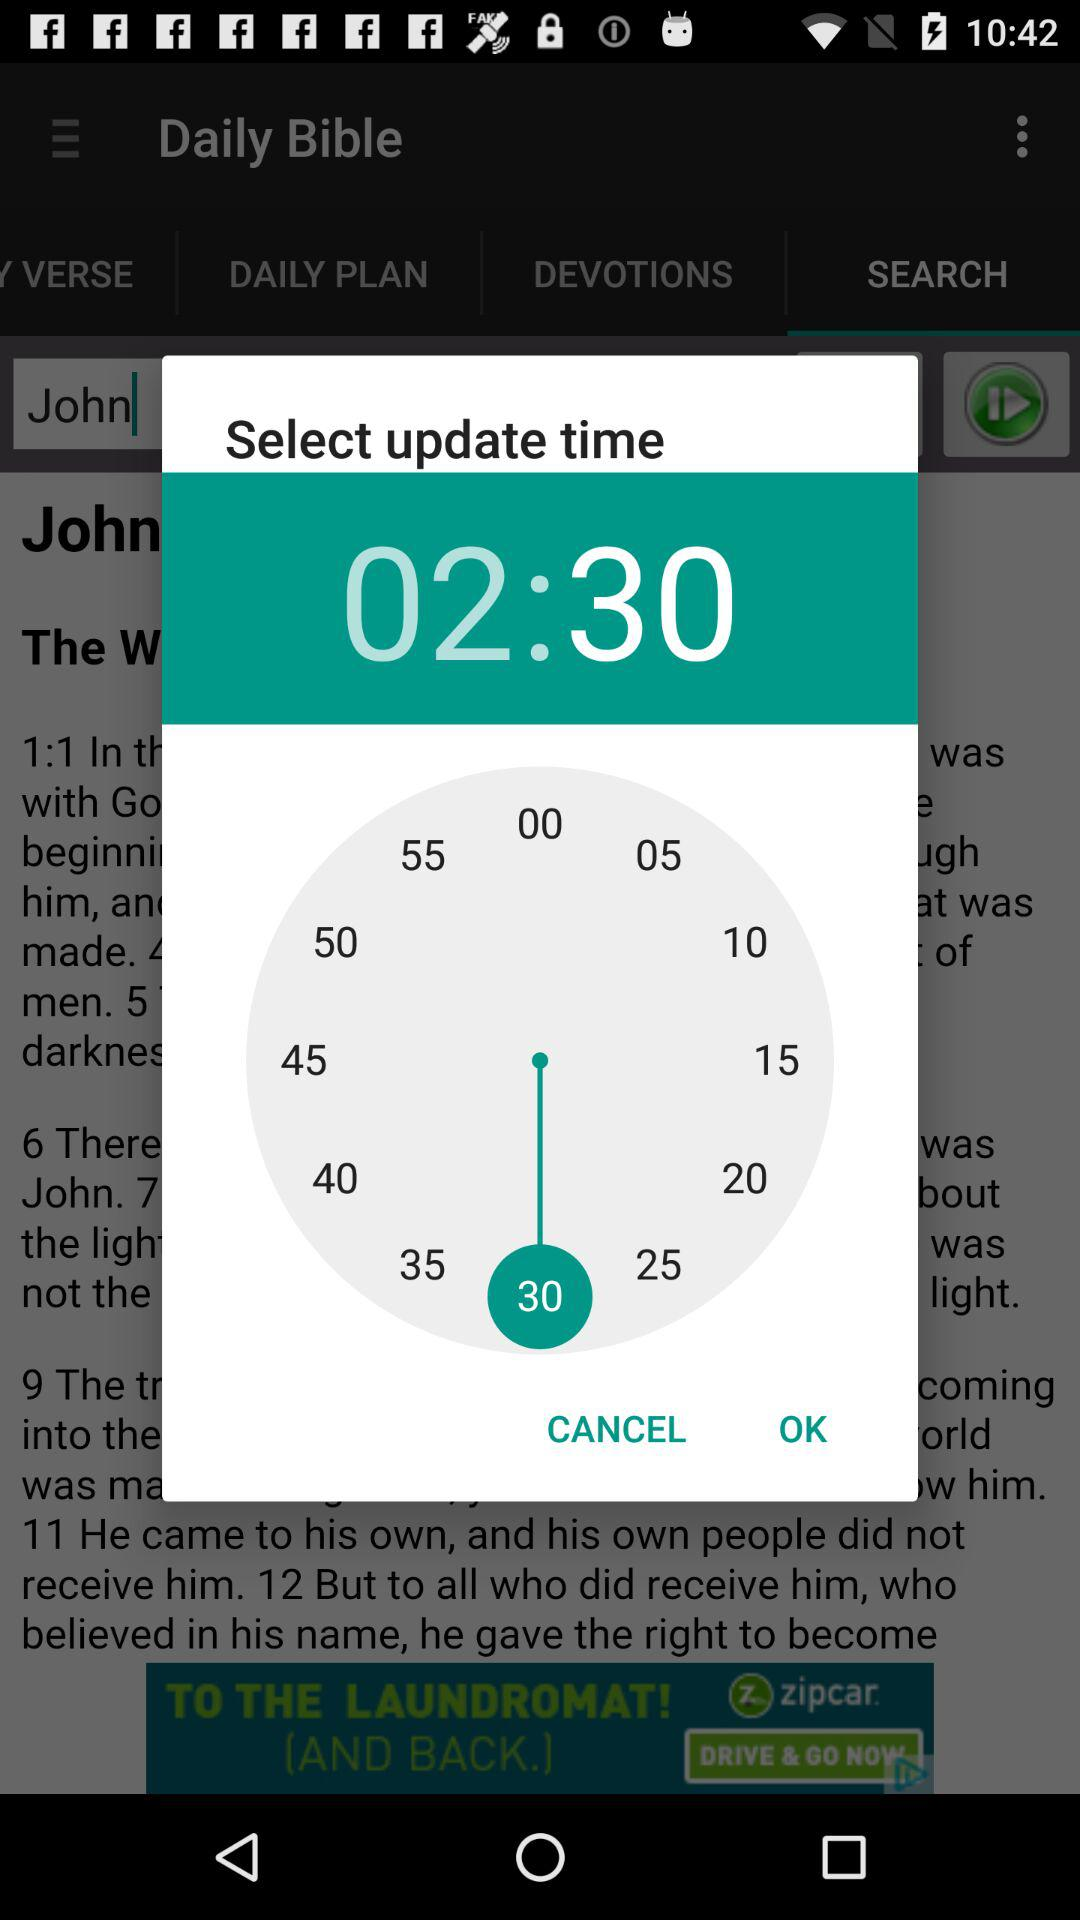Which number is highlighted in blue?
When the provided information is insufficient, respond with <no answer>. <no answer> 